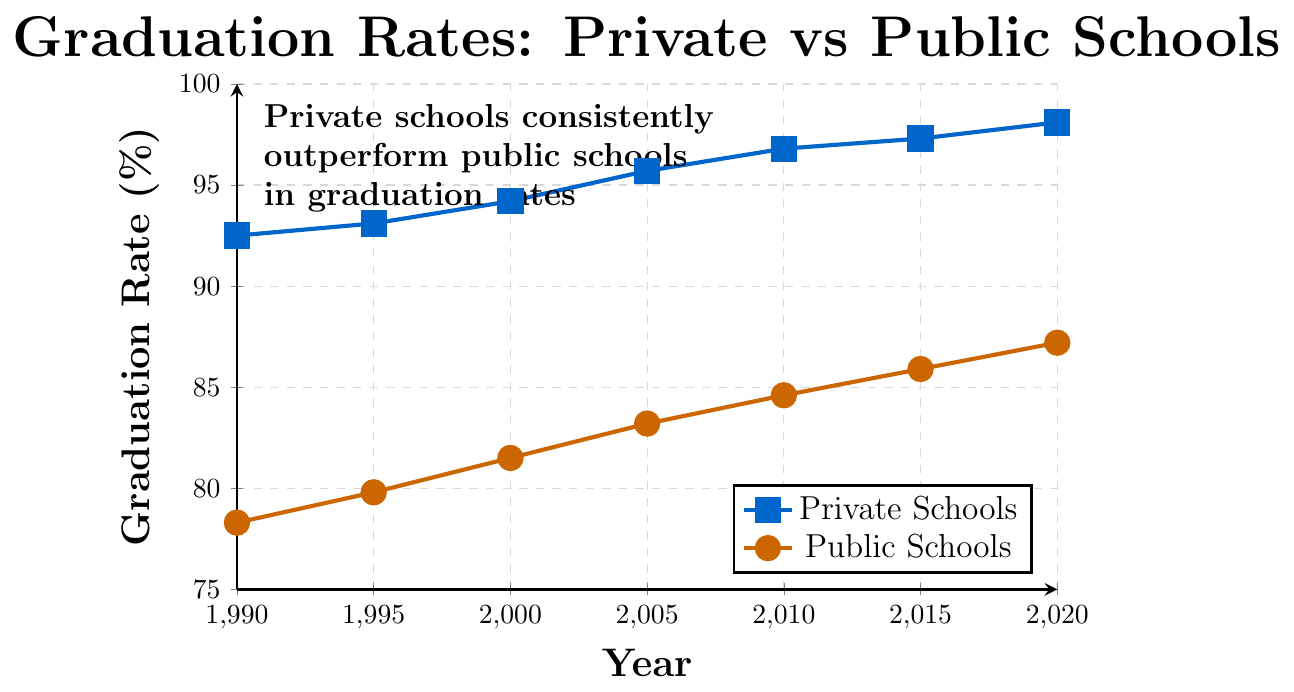What year shows the highest graduation rate for private schools? To find the highest graduation rate for private schools, look at the y-values corresponding to "Private Schools" line and identify the largest value and its associated year.
Answer: 2020 How much did the graduation rate for public schools increase from 1990 to 2020? Subtract the graduation rate of public schools in 1990 from that in 2020. Calculation: 87.2% - 78.3% = 8.9%
Answer: 8.9% In which year is the gap between private and public school graduation rates the smallest, and what is the gap? To find the smallest gap, calculate the differences between the two sets of values for each year. Identify the smallest difference and the corresponding year.
Answer: 2020, 10.9% Between 1995 and 2010, which type of school showed a larger increase in graduation rates? Calculate the difference in graduation rates from 1995 to 2010 for both types of schools. For private schools: 96.8% - 93.1% = 3.7%. For public schools: 84.6% - 79.8% = 4.8%. Compare the two differences.
Answer: Public schools, 4.8% What is the average graduation rate of private schools across all the years shown? Average involves summing up all the graduation rates for private schools and then dividing by the total number of years (7). Calculation: (92.5 + 93.1 + 94.2 + 95.7 + 96.8 + 97.3 + 98.1) / 7 = 95.39%
Answer: 95.39% What trend can be observed in the graduation rates of both private and public schools from 1990 to 2020? Look at the general direction of the lines for both types of schools from 1990 to 2020. Both lines show an upward trend, indicating an increase in graduation rates over time for both types of schools.
Answer: Upward trend How do the graduation rates of private schools in 1995 and 2020 compare? Compare the values for private schools in 1995 and 2020. The graduation rate in 1995 is 93.1%, and in 2020, it is 98.1%. Calculate the difference: 98.1% - 93.1% = 5%.
Answer: 5% higher in 2020 